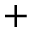<formula> <loc_0><loc_0><loc_500><loc_500>^ { + }</formula> 